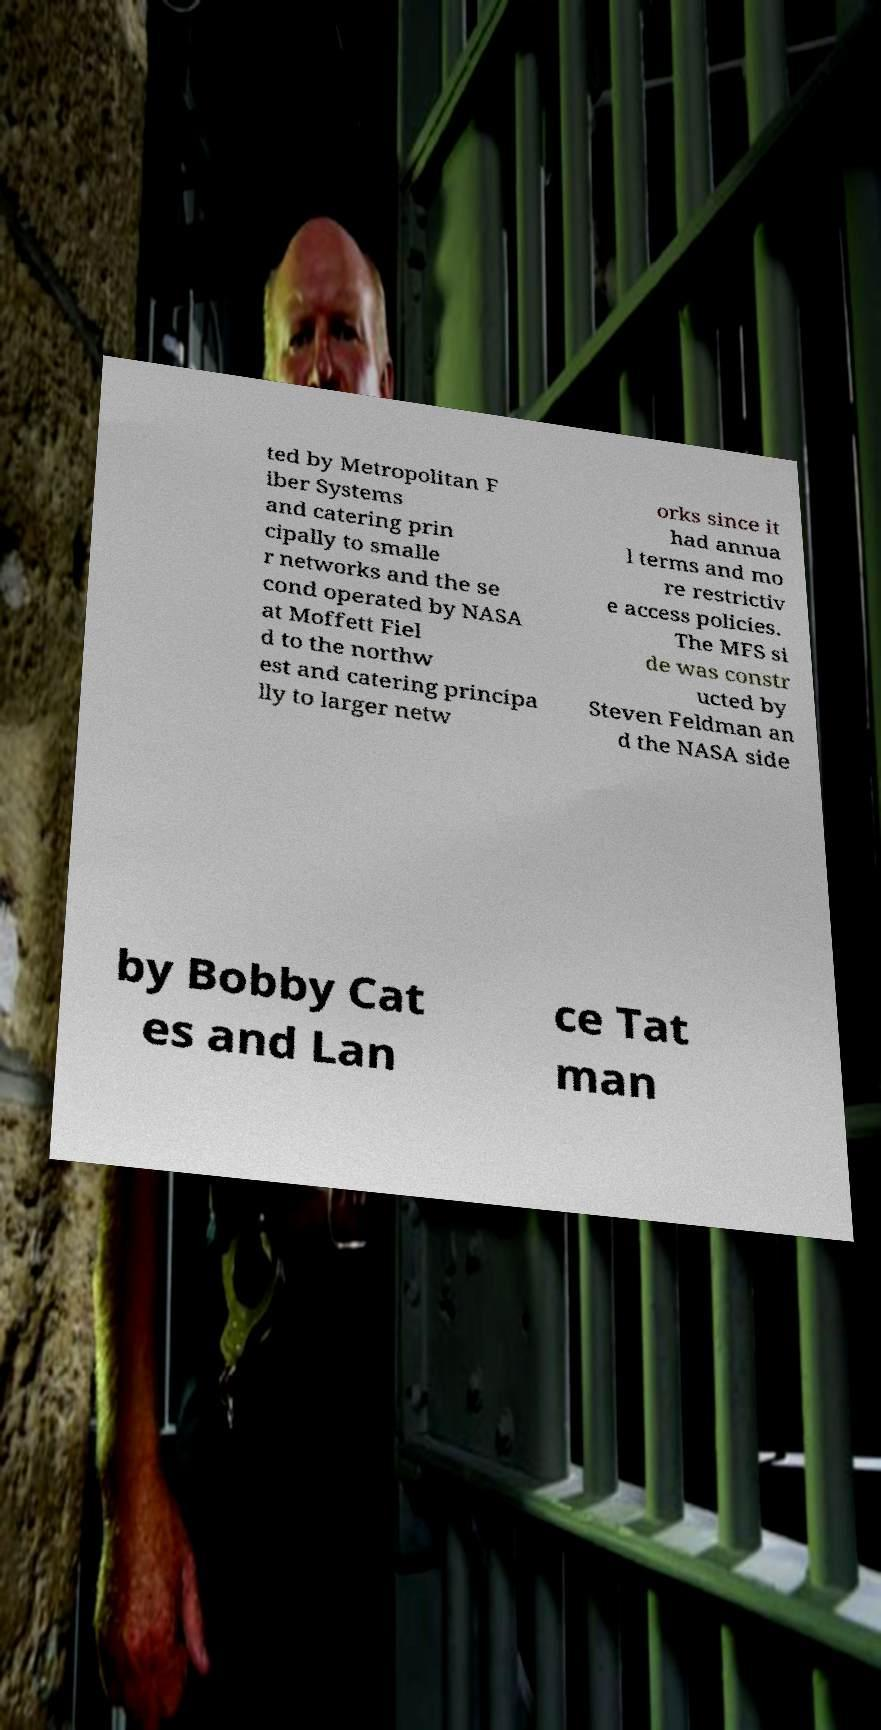What messages or text are displayed in this image? I need them in a readable, typed format. ted by Metropolitan F iber Systems and catering prin cipally to smalle r networks and the se cond operated by NASA at Moffett Fiel d to the northw est and catering principa lly to larger netw orks since it had annua l terms and mo re restrictiv e access policies. The MFS si de was constr ucted by Steven Feldman an d the NASA side by Bobby Cat es and Lan ce Tat man 